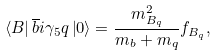Convert formula to latex. <formula><loc_0><loc_0><loc_500><loc_500>\left \langle B \right | \overline { b } i \gamma _ { 5 } q \left | 0 \right \rangle = \frac { m _ { B _ { q } } ^ { 2 } } { m _ { b } + m _ { q } } f _ { B _ { q } } ,</formula> 